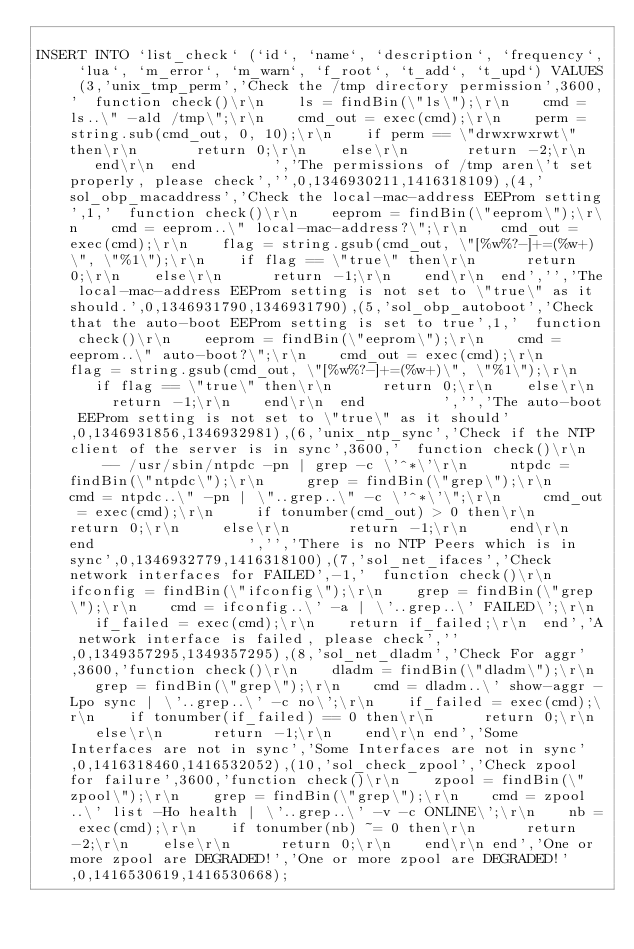Convert code to text. <code><loc_0><loc_0><loc_500><loc_500><_SQL_>
INSERT INTO `list_check` (`id`, `name`, `description`, `frequency`, `lua`, `m_error`, `m_warn`, `f_root`, `t_add`, `t_upd`) VALUES (3,'unix_tmp_perm','Check the /tmp directory permission',3600,'  function check()\r\n    ls = findBin(\"ls\");\r\n    cmd = ls..\" -ald /tmp\";\r\n    cmd_out = exec(cmd);\r\n    perm = string.sub(cmd_out, 0, 10);\r\n    if perm == \"drwxrwxrwt\" then\r\n       return 0;\r\n    else\r\n       return -2;\r\n    end\r\n  end         ','The permissions of /tmp aren\'t set properly, please check','',0,1346930211,1416318109),(4,'sol_obp_macaddress','Check the local-mac-address EEProm setting',1,'  function check()\r\n    eeprom = findBin(\"eeprom\");\r\n    cmd = eeprom..\" local-mac-address?\";\r\n    cmd_out = exec(cmd);\r\n    flag = string.gsub(cmd_out, \"[%w%?-]+=(%w+)\", \"%1\");\r\n    if flag == \"true\" then\r\n      return 0;\r\n    else\r\n      return -1;\r\n    end\r\n  end','','The local-mac-address EEProm setting is not set to \"true\" as it should.',0,1346931790,1346931790),(5,'sol_obp_autoboot','Check that the auto-boot EEProm setting is set to true',1,'  function check()\r\n    eeprom = findBin(\"eeprom\");\r\n    cmd = eeprom..\" auto-boot?\";\r\n    cmd_out = exec(cmd);\r\n    flag = string.gsub(cmd_out, \"[%w%?-]+=(%w+)\", \"%1\");\r\n    if flag == \"true\" then\r\n      return 0;\r\n    else\r\n      return -1;\r\n    end\r\n  end         ','','The auto-boot EEProm setting is not set to \"true\" as it should',0,1346931856,1346932981),(6,'unix_ntp_sync','Check if the NTP client of the server is in sync',3600,'  function check()\r\n     -- /usr/sbin/ntpdc -pn | grep -c \'^*\'\r\n     ntpdc = findBin(\"ntpdc\");\r\n     grep = findBin(\"grep\");\r\n     cmd = ntpdc..\" -pn | \"..grep..\" -c \'^*\'\";\r\n     cmd_out = exec(cmd);\r\n     if tonumber(cmd_out) > 0 then\r\n       return 0;\r\n     else\r\n       return -1;\r\n     end\r\n  end                  ','','There is no NTP Peers which is in sync',0,1346932779,1416318100),(7,'sol_net_ifaces','Check network interfaces for FAILED',-1,'  function check()\r\n    ifconfig = findBin(\"ifconfig\");\r\n    grep = findBin(\"grep\");\r\n    cmd = ifconfig..\' -a | \'..grep..\' FAILED\';\r\n    if_failed = exec(cmd);\r\n    return if_failed;\r\n  end','A network interface is failed, please check','',0,1349357295,1349357295),(8,'sol_net_dladm','Check For aggr',3600,'function check()\r\n    dladm = findBin(\"dladm\");\r\n    grep = findBin(\"grep\");\r\n    cmd = dladm..\' show-aggr -Lpo sync | \'..grep..\' -c no\';\r\n    if_failed = exec(cmd);\r\n    if tonumber(if_failed) == 0 then\r\n      return 0;\r\n    else\r\n      return -1;\r\n    end\r\n end','Some Interfaces are not in sync','Some Interfaces are not in sync',0,1416318460,1416532052),(10,'sol_check_zpool','Check zpool for failure',3600,'function check()\r\n    zpool = findBin(\"zpool\");\r\n    grep = findBin(\"grep\");\r\n    cmd = zpool..\' list -Ho health | \'..grep..\' -v -c ONLINE\';\r\n    nb = exec(cmd);\r\n    if tonumber(nb) ~= 0 then\r\n      return -2;\r\n    else\r\n      return 0;\r\n    end\r\n end','One or more zpool are DEGRADED!','One or more zpool are DEGRADED!',0,1416530619,1416530668);


</code> 